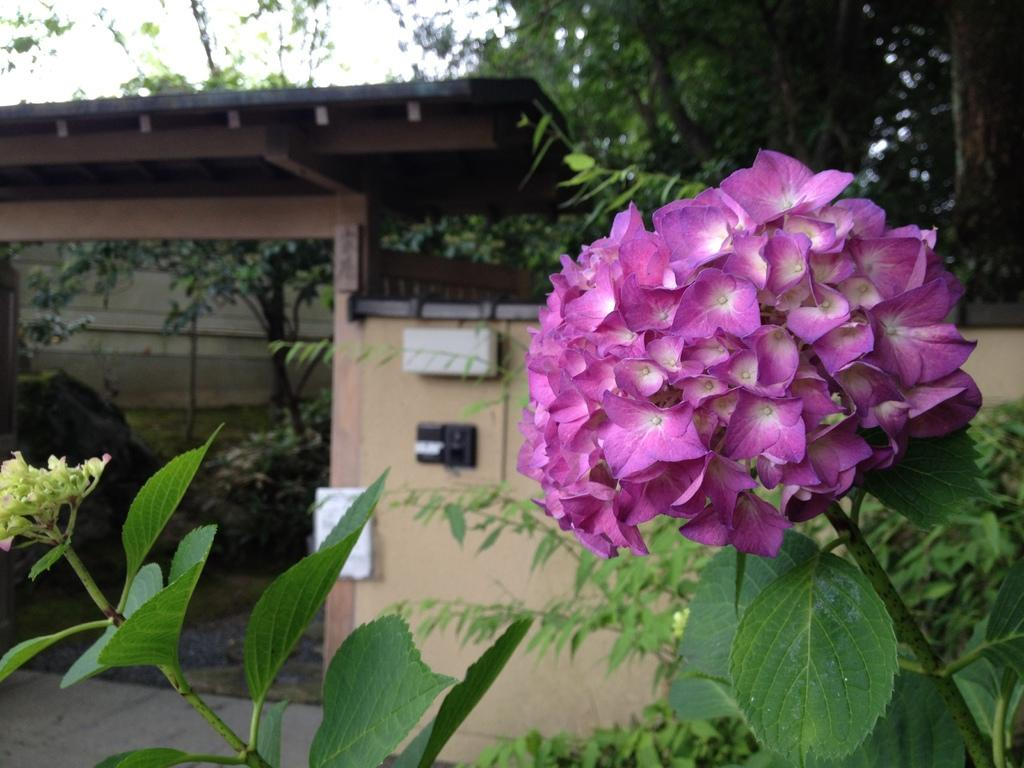What is the main subject of the image? There is a bunch of flowers in the image. How are the flowers arranged or connected? The flowers are attached to stems. What can be seen in the background of the image? There is a wall, trees, and a house visible in the image. What is visible at the top of the image? The sky is visible in the image. What letters are being spelled out by the flowers in the image? There are no letters present in the image; it features a bunch of flowers attached to stems. Can you tell me how many visitors are standing next to the flowers in the image? There are no visitors present in the image; it only features a bunch of flowers, stems, a wall, trees, a house, and the sky. 